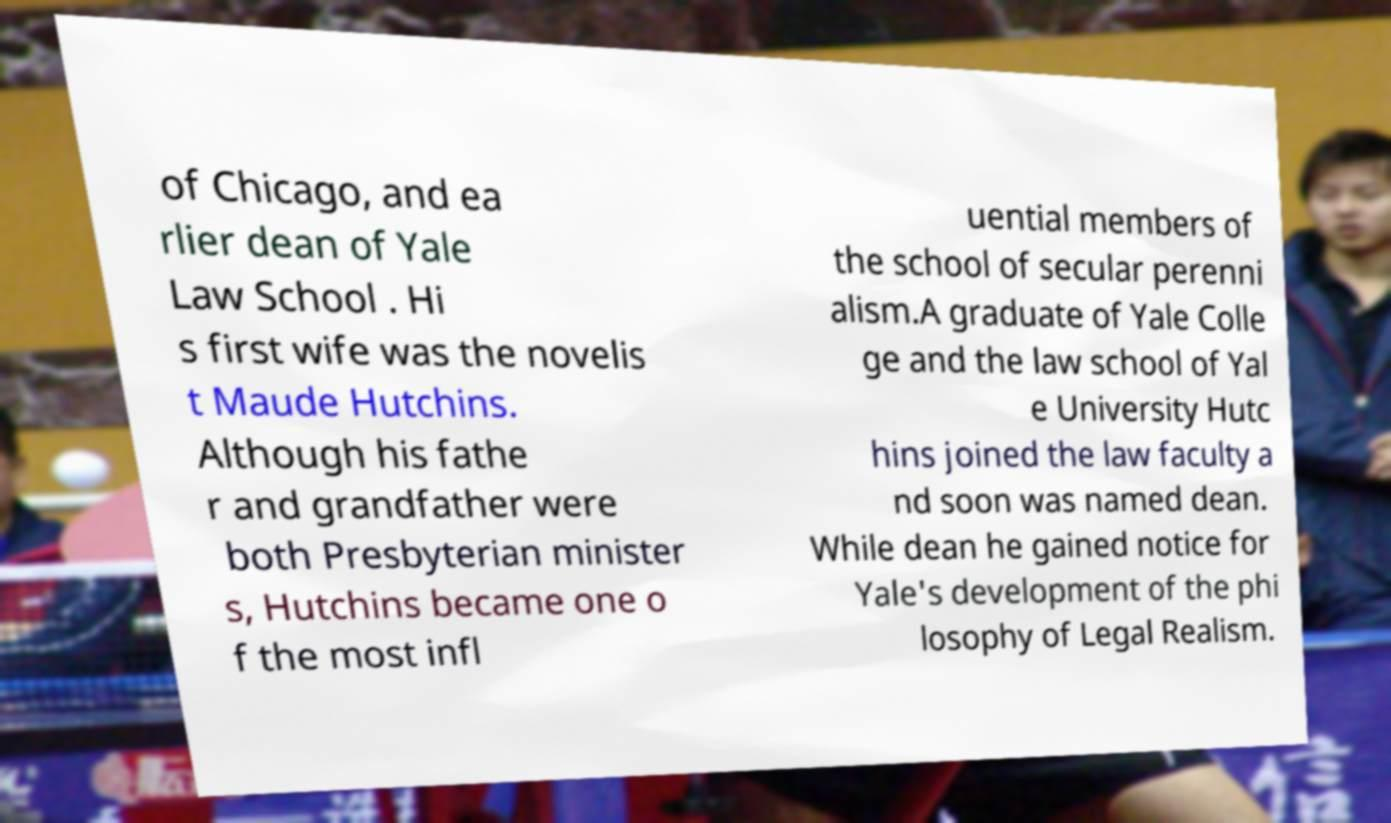Please identify and transcribe the text found in this image. of Chicago, and ea rlier dean of Yale Law School . Hi s first wife was the novelis t Maude Hutchins. Although his fathe r and grandfather were both Presbyterian minister s, Hutchins became one o f the most infl uential members of the school of secular perenni alism.A graduate of Yale Colle ge and the law school of Yal e University Hutc hins joined the law faculty a nd soon was named dean. While dean he gained notice for Yale's development of the phi losophy of Legal Realism. 